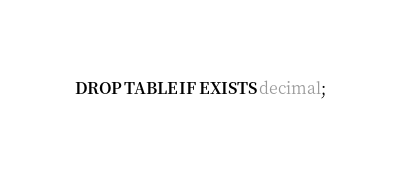Convert code to text. <code><loc_0><loc_0><loc_500><loc_500><_SQL_>DROP TABLE IF EXISTS decimal;
</code> 